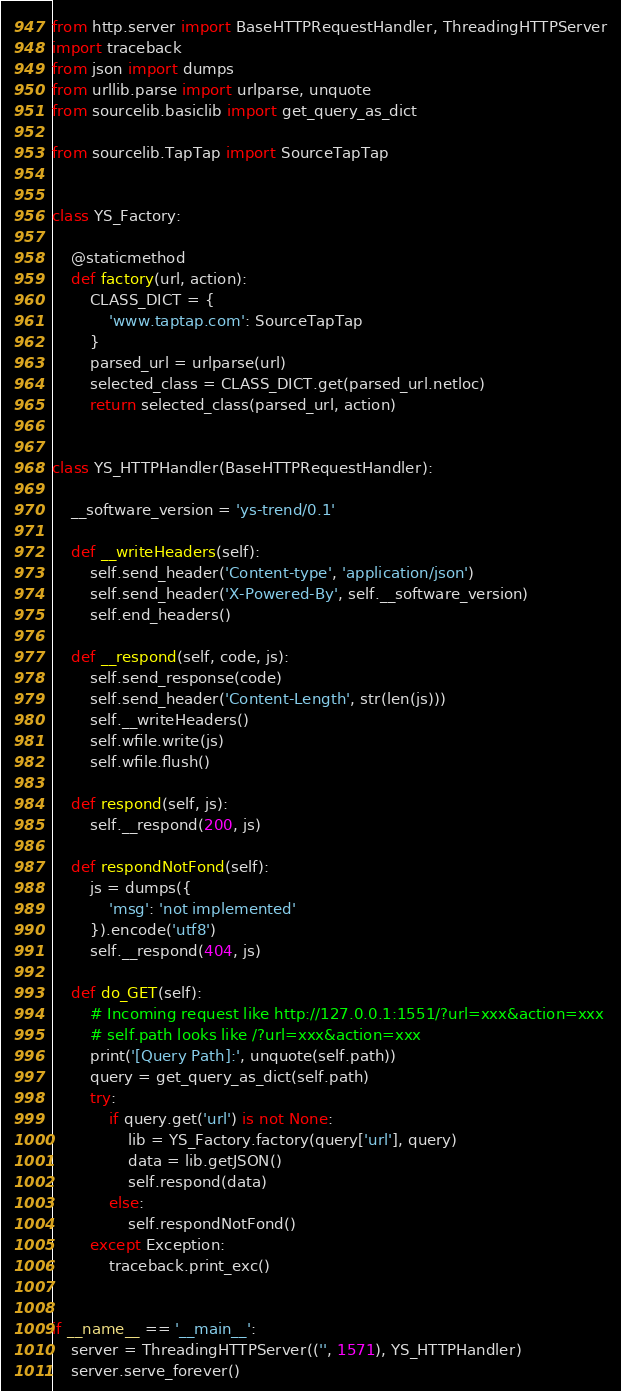<code> <loc_0><loc_0><loc_500><loc_500><_Python_>from http.server import BaseHTTPRequestHandler, ThreadingHTTPServer
import traceback
from json import dumps
from urllib.parse import urlparse, unquote
from sourcelib.basiclib import get_query_as_dict

from sourcelib.TapTap import SourceTapTap


class YS_Factory:

    @staticmethod
    def factory(url, action):
        CLASS_DICT = {
            'www.taptap.com': SourceTapTap
        }
        parsed_url = urlparse(url)
        selected_class = CLASS_DICT.get(parsed_url.netloc)
        return selected_class(parsed_url, action)


class YS_HTTPHandler(BaseHTTPRequestHandler):

    __software_version = 'ys-trend/0.1'

    def __writeHeaders(self):
        self.send_header('Content-type', 'application/json')
        self.send_header('X-Powered-By', self.__software_version)
        self.end_headers()

    def __respond(self, code, js):
        self.send_response(code)
        self.send_header('Content-Length', str(len(js)))
        self.__writeHeaders()
        self.wfile.write(js)
        self.wfile.flush()

    def respond(self, js):
        self.__respond(200, js)

    def respondNotFond(self):
        js = dumps({
            'msg': 'not implemented'
        }).encode('utf8')
        self.__respond(404, js)

    def do_GET(self):
        # Incoming request like http://127.0.0.1:1551/?url=xxx&action=xxx
        # self.path looks like /?url=xxx&action=xxx
        print('[Query Path]:', unquote(self.path))
        query = get_query_as_dict(self.path)
        try:
            if query.get('url') is not None:
                lib = YS_Factory.factory(query['url'], query)
                data = lib.getJSON()
                self.respond(data)
            else:
                self.respondNotFond()
        except Exception:
            traceback.print_exc()


if __name__ == '__main__':
    server = ThreadingHTTPServer(('', 1571), YS_HTTPHandler)
    server.serve_forever()
</code> 